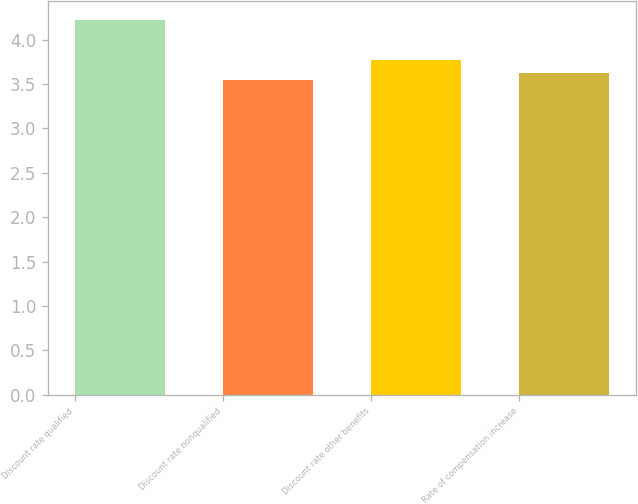Convert chart to OTSL. <chart><loc_0><loc_0><loc_500><loc_500><bar_chart><fcel>Discount rate qualified<fcel>Discount rate nonqualified<fcel>Discount rate other benefits<fcel>Rate of compensation increase<nl><fcel>4.22<fcel>3.55<fcel>3.77<fcel>3.62<nl></chart> 